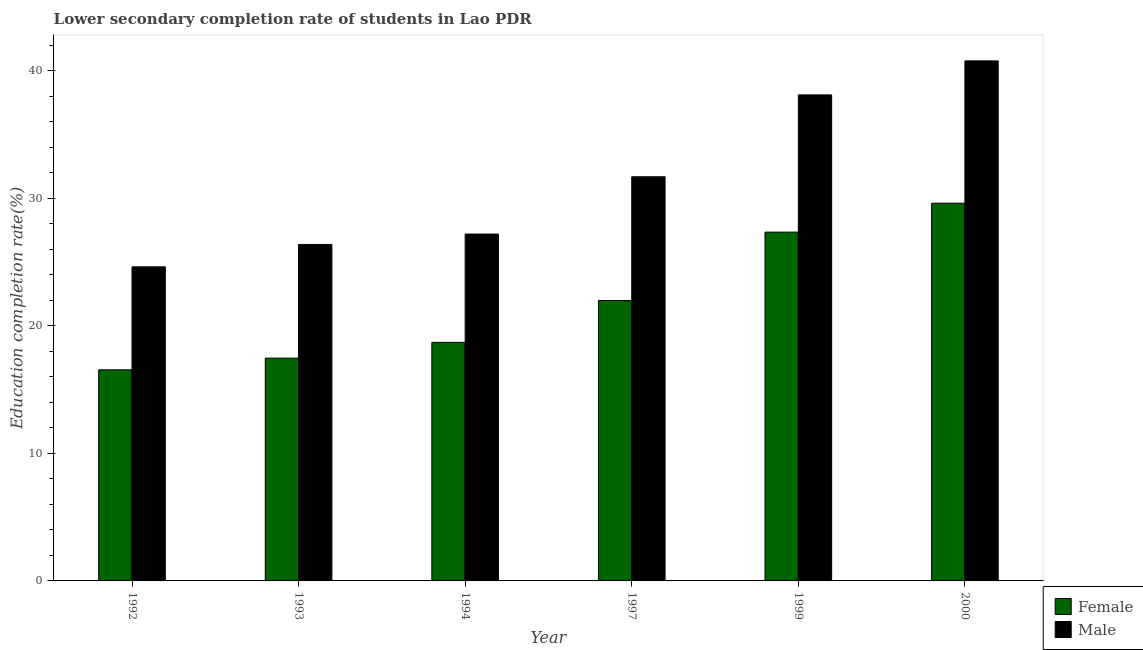How many bars are there on the 4th tick from the left?
Provide a short and direct response. 2. What is the label of the 1st group of bars from the left?
Offer a very short reply. 1992. In how many cases, is the number of bars for a given year not equal to the number of legend labels?
Your answer should be compact. 0. What is the education completion rate of female students in 2000?
Your answer should be compact. 29.62. Across all years, what is the maximum education completion rate of female students?
Ensure brevity in your answer.  29.62. Across all years, what is the minimum education completion rate of female students?
Make the answer very short. 16.55. In which year was the education completion rate of male students minimum?
Keep it short and to the point. 1992. What is the total education completion rate of female students in the graph?
Provide a succinct answer. 131.68. What is the difference between the education completion rate of female students in 1993 and that in 1997?
Keep it short and to the point. -4.52. What is the difference between the education completion rate of female students in 1993 and the education completion rate of male students in 1999?
Keep it short and to the point. -9.88. What is the average education completion rate of female students per year?
Your answer should be very brief. 21.95. In the year 1993, what is the difference between the education completion rate of male students and education completion rate of female students?
Offer a very short reply. 0. What is the ratio of the education completion rate of male students in 1992 to that in 1993?
Your answer should be compact. 0.93. What is the difference between the highest and the second highest education completion rate of male students?
Your response must be concise. 2.67. What is the difference between the highest and the lowest education completion rate of male students?
Provide a short and direct response. 16.15. Is the sum of the education completion rate of male students in 1992 and 2000 greater than the maximum education completion rate of female students across all years?
Ensure brevity in your answer.  Yes. What does the 2nd bar from the left in 1992 represents?
Give a very brief answer. Male. How many bars are there?
Give a very brief answer. 12. Are all the bars in the graph horizontal?
Keep it short and to the point. No. How many years are there in the graph?
Offer a very short reply. 6. What is the difference between two consecutive major ticks on the Y-axis?
Keep it short and to the point. 10. Does the graph contain any zero values?
Offer a very short reply. No. Does the graph contain grids?
Your response must be concise. No. How many legend labels are there?
Offer a very short reply. 2. How are the legend labels stacked?
Give a very brief answer. Vertical. What is the title of the graph?
Give a very brief answer. Lower secondary completion rate of students in Lao PDR. What is the label or title of the Y-axis?
Offer a terse response. Education completion rate(%). What is the Education completion rate(%) of Female in 1992?
Ensure brevity in your answer.  16.55. What is the Education completion rate(%) of Male in 1992?
Make the answer very short. 24.63. What is the Education completion rate(%) in Female in 1993?
Ensure brevity in your answer.  17.47. What is the Education completion rate(%) in Male in 1993?
Your answer should be very brief. 26.38. What is the Education completion rate(%) in Female in 1994?
Give a very brief answer. 18.7. What is the Education completion rate(%) of Male in 1994?
Provide a succinct answer. 27.2. What is the Education completion rate(%) of Female in 1997?
Ensure brevity in your answer.  21.99. What is the Education completion rate(%) in Male in 1997?
Provide a short and direct response. 31.69. What is the Education completion rate(%) of Female in 1999?
Keep it short and to the point. 27.35. What is the Education completion rate(%) in Male in 1999?
Provide a succinct answer. 38.11. What is the Education completion rate(%) of Female in 2000?
Offer a very short reply. 29.62. What is the Education completion rate(%) in Male in 2000?
Your response must be concise. 40.78. Across all years, what is the maximum Education completion rate(%) of Female?
Give a very brief answer. 29.62. Across all years, what is the maximum Education completion rate(%) in Male?
Offer a terse response. 40.78. Across all years, what is the minimum Education completion rate(%) of Female?
Provide a succinct answer. 16.55. Across all years, what is the minimum Education completion rate(%) in Male?
Offer a very short reply. 24.63. What is the total Education completion rate(%) of Female in the graph?
Your answer should be compact. 131.68. What is the total Education completion rate(%) in Male in the graph?
Keep it short and to the point. 188.78. What is the difference between the Education completion rate(%) in Female in 1992 and that in 1993?
Ensure brevity in your answer.  -0.92. What is the difference between the Education completion rate(%) in Male in 1992 and that in 1993?
Keep it short and to the point. -1.76. What is the difference between the Education completion rate(%) in Female in 1992 and that in 1994?
Your answer should be compact. -2.15. What is the difference between the Education completion rate(%) of Male in 1992 and that in 1994?
Keep it short and to the point. -2.57. What is the difference between the Education completion rate(%) of Female in 1992 and that in 1997?
Make the answer very short. -5.43. What is the difference between the Education completion rate(%) in Male in 1992 and that in 1997?
Your response must be concise. -7.06. What is the difference between the Education completion rate(%) of Female in 1992 and that in 1999?
Ensure brevity in your answer.  -10.79. What is the difference between the Education completion rate(%) of Male in 1992 and that in 1999?
Keep it short and to the point. -13.48. What is the difference between the Education completion rate(%) in Female in 1992 and that in 2000?
Your answer should be compact. -13.06. What is the difference between the Education completion rate(%) in Male in 1992 and that in 2000?
Keep it short and to the point. -16.15. What is the difference between the Education completion rate(%) in Female in 1993 and that in 1994?
Offer a very short reply. -1.23. What is the difference between the Education completion rate(%) in Male in 1993 and that in 1994?
Give a very brief answer. -0.81. What is the difference between the Education completion rate(%) in Female in 1993 and that in 1997?
Ensure brevity in your answer.  -4.52. What is the difference between the Education completion rate(%) in Male in 1993 and that in 1997?
Ensure brevity in your answer.  -5.31. What is the difference between the Education completion rate(%) of Female in 1993 and that in 1999?
Make the answer very short. -9.88. What is the difference between the Education completion rate(%) in Male in 1993 and that in 1999?
Provide a short and direct response. -11.73. What is the difference between the Education completion rate(%) in Female in 1993 and that in 2000?
Your answer should be very brief. -12.15. What is the difference between the Education completion rate(%) of Male in 1993 and that in 2000?
Offer a terse response. -14.39. What is the difference between the Education completion rate(%) in Female in 1994 and that in 1997?
Your response must be concise. -3.28. What is the difference between the Education completion rate(%) of Male in 1994 and that in 1997?
Ensure brevity in your answer.  -4.49. What is the difference between the Education completion rate(%) of Female in 1994 and that in 1999?
Give a very brief answer. -8.64. What is the difference between the Education completion rate(%) in Male in 1994 and that in 1999?
Provide a succinct answer. -10.91. What is the difference between the Education completion rate(%) of Female in 1994 and that in 2000?
Provide a short and direct response. -10.91. What is the difference between the Education completion rate(%) of Male in 1994 and that in 2000?
Provide a succinct answer. -13.58. What is the difference between the Education completion rate(%) of Female in 1997 and that in 1999?
Offer a very short reply. -5.36. What is the difference between the Education completion rate(%) in Male in 1997 and that in 1999?
Your answer should be compact. -6.42. What is the difference between the Education completion rate(%) of Female in 1997 and that in 2000?
Keep it short and to the point. -7.63. What is the difference between the Education completion rate(%) of Male in 1997 and that in 2000?
Your answer should be compact. -9.09. What is the difference between the Education completion rate(%) in Female in 1999 and that in 2000?
Keep it short and to the point. -2.27. What is the difference between the Education completion rate(%) of Male in 1999 and that in 2000?
Provide a succinct answer. -2.67. What is the difference between the Education completion rate(%) in Female in 1992 and the Education completion rate(%) in Male in 1993?
Ensure brevity in your answer.  -9.83. What is the difference between the Education completion rate(%) in Female in 1992 and the Education completion rate(%) in Male in 1994?
Your answer should be compact. -10.64. What is the difference between the Education completion rate(%) of Female in 1992 and the Education completion rate(%) of Male in 1997?
Provide a short and direct response. -15.14. What is the difference between the Education completion rate(%) of Female in 1992 and the Education completion rate(%) of Male in 1999?
Offer a terse response. -21.56. What is the difference between the Education completion rate(%) of Female in 1992 and the Education completion rate(%) of Male in 2000?
Your answer should be compact. -24.22. What is the difference between the Education completion rate(%) in Female in 1993 and the Education completion rate(%) in Male in 1994?
Your answer should be compact. -9.73. What is the difference between the Education completion rate(%) of Female in 1993 and the Education completion rate(%) of Male in 1997?
Keep it short and to the point. -14.22. What is the difference between the Education completion rate(%) in Female in 1993 and the Education completion rate(%) in Male in 1999?
Offer a terse response. -20.64. What is the difference between the Education completion rate(%) of Female in 1993 and the Education completion rate(%) of Male in 2000?
Keep it short and to the point. -23.31. What is the difference between the Education completion rate(%) of Female in 1994 and the Education completion rate(%) of Male in 1997?
Make the answer very short. -12.99. What is the difference between the Education completion rate(%) in Female in 1994 and the Education completion rate(%) in Male in 1999?
Keep it short and to the point. -19.4. What is the difference between the Education completion rate(%) in Female in 1994 and the Education completion rate(%) in Male in 2000?
Give a very brief answer. -22.07. What is the difference between the Education completion rate(%) in Female in 1997 and the Education completion rate(%) in Male in 1999?
Your response must be concise. -16.12. What is the difference between the Education completion rate(%) in Female in 1997 and the Education completion rate(%) in Male in 2000?
Provide a succinct answer. -18.79. What is the difference between the Education completion rate(%) in Female in 1999 and the Education completion rate(%) in Male in 2000?
Give a very brief answer. -13.43. What is the average Education completion rate(%) of Female per year?
Give a very brief answer. 21.95. What is the average Education completion rate(%) of Male per year?
Ensure brevity in your answer.  31.46. In the year 1992, what is the difference between the Education completion rate(%) of Female and Education completion rate(%) of Male?
Offer a very short reply. -8.07. In the year 1993, what is the difference between the Education completion rate(%) of Female and Education completion rate(%) of Male?
Give a very brief answer. -8.91. In the year 1994, what is the difference between the Education completion rate(%) in Female and Education completion rate(%) in Male?
Ensure brevity in your answer.  -8.49. In the year 1997, what is the difference between the Education completion rate(%) in Female and Education completion rate(%) in Male?
Keep it short and to the point. -9.7. In the year 1999, what is the difference between the Education completion rate(%) in Female and Education completion rate(%) in Male?
Offer a very short reply. -10.76. In the year 2000, what is the difference between the Education completion rate(%) in Female and Education completion rate(%) in Male?
Provide a short and direct response. -11.16. What is the ratio of the Education completion rate(%) of Female in 1992 to that in 1993?
Make the answer very short. 0.95. What is the ratio of the Education completion rate(%) of Male in 1992 to that in 1993?
Your answer should be very brief. 0.93. What is the ratio of the Education completion rate(%) in Female in 1992 to that in 1994?
Your answer should be very brief. 0.89. What is the ratio of the Education completion rate(%) in Male in 1992 to that in 1994?
Offer a terse response. 0.91. What is the ratio of the Education completion rate(%) of Female in 1992 to that in 1997?
Provide a succinct answer. 0.75. What is the ratio of the Education completion rate(%) in Male in 1992 to that in 1997?
Offer a very short reply. 0.78. What is the ratio of the Education completion rate(%) in Female in 1992 to that in 1999?
Offer a very short reply. 0.61. What is the ratio of the Education completion rate(%) of Male in 1992 to that in 1999?
Ensure brevity in your answer.  0.65. What is the ratio of the Education completion rate(%) of Female in 1992 to that in 2000?
Give a very brief answer. 0.56. What is the ratio of the Education completion rate(%) of Male in 1992 to that in 2000?
Keep it short and to the point. 0.6. What is the ratio of the Education completion rate(%) in Female in 1993 to that in 1994?
Give a very brief answer. 0.93. What is the ratio of the Education completion rate(%) of Male in 1993 to that in 1994?
Give a very brief answer. 0.97. What is the ratio of the Education completion rate(%) in Female in 1993 to that in 1997?
Provide a short and direct response. 0.79. What is the ratio of the Education completion rate(%) of Male in 1993 to that in 1997?
Keep it short and to the point. 0.83. What is the ratio of the Education completion rate(%) of Female in 1993 to that in 1999?
Offer a very short reply. 0.64. What is the ratio of the Education completion rate(%) of Male in 1993 to that in 1999?
Your response must be concise. 0.69. What is the ratio of the Education completion rate(%) in Female in 1993 to that in 2000?
Offer a very short reply. 0.59. What is the ratio of the Education completion rate(%) of Male in 1993 to that in 2000?
Make the answer very short. 0.65. What is the ratio of the Education completion rate(%) in Female in 1994 to that in 1997?
Ensure brevity in your answer.  0.85. What is the ratio of the Education completion rate(%) of Male in 1994 to that in 1997?
Your answer should be very brief. 0.86. What is the ratio of the Education completion rate(%) in Female in 1994 to that in 1999?
Offer a very short reply. 0.68. What is the ratio of the Education completion rate(%) in Male in 1994 to that in 1999?
Offer a very short reply. 0.71. What is the ratio of the Education completion rate(%) of Female in 1994 to that in 2000?
Provide a short and direct response. 0.63. What is the ratio of the Education completion rate(%) of Male in 1994 to that in 2000?
Ensure brevity in your answer.  0.67. What is the ratio of the Education completion rate(%) in Female in 1997 to that in 1999?
Provide a short and direct response. 0.8. What is the ratio of the Education completion rate(%) of Male in 1997 to that in 1999?
Keep it short and to the point. 0.83. What is the ratio of the Education completion rate(%) of Female in 1997 to that in 2000?
Your response must be concise. 0.74. What is the ratio of the Education completion rate(%) of Male in 1997 to that in 2000?
Your response must be concise. 0.78. What is the ratio of the Education completion rate(%) of Female in 1999 to that in 2000?
Provide a succinct answer. 0.92. What is the ratio of the Education completion rate(%) in Male in 1999 to that in 2000?
Offer a very short reply. 0.93. What is the difference between the highest and the second highest Education completion rate(%) in Female?
Ensure brevity in your answer.  2.27. What is the difference between the highest and the second highest Education completion rate(%) in Male?
Your answer should be compact. 2.67. What is the difference between the highest and the lowest Education completion rate(%) in Female?
Provide a short and direct response. 13.06. What is the difference between the highest and the lowest Education completion rate(%) in Male?
Offer a terse response. 16.15. 